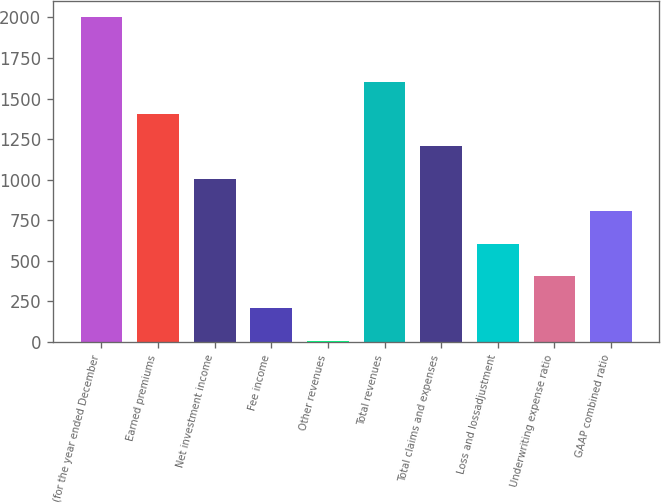Convert chart. <chart><loc_0><loc_0><loc_500><loc_500><bar_chart><fcel>(for the year ended December<fcel>Earned premiums<fcel>Net investment income<fcel>Fee income<fcel>Other revenues<fcel>Total revenues<fcel>Total claims and expenses<fcel>Loss and lossadjustment<fcel>Underwriting expense ratio<fcel>GAAP combined ratio<nl><fcel>2003<fcel>1404.5<fcel>1005.5<fcel>207.5<fcel>8<fcel>1604<fcel>1205<fcel>606.5<fcel>407<fcel>806<nl></chart> 